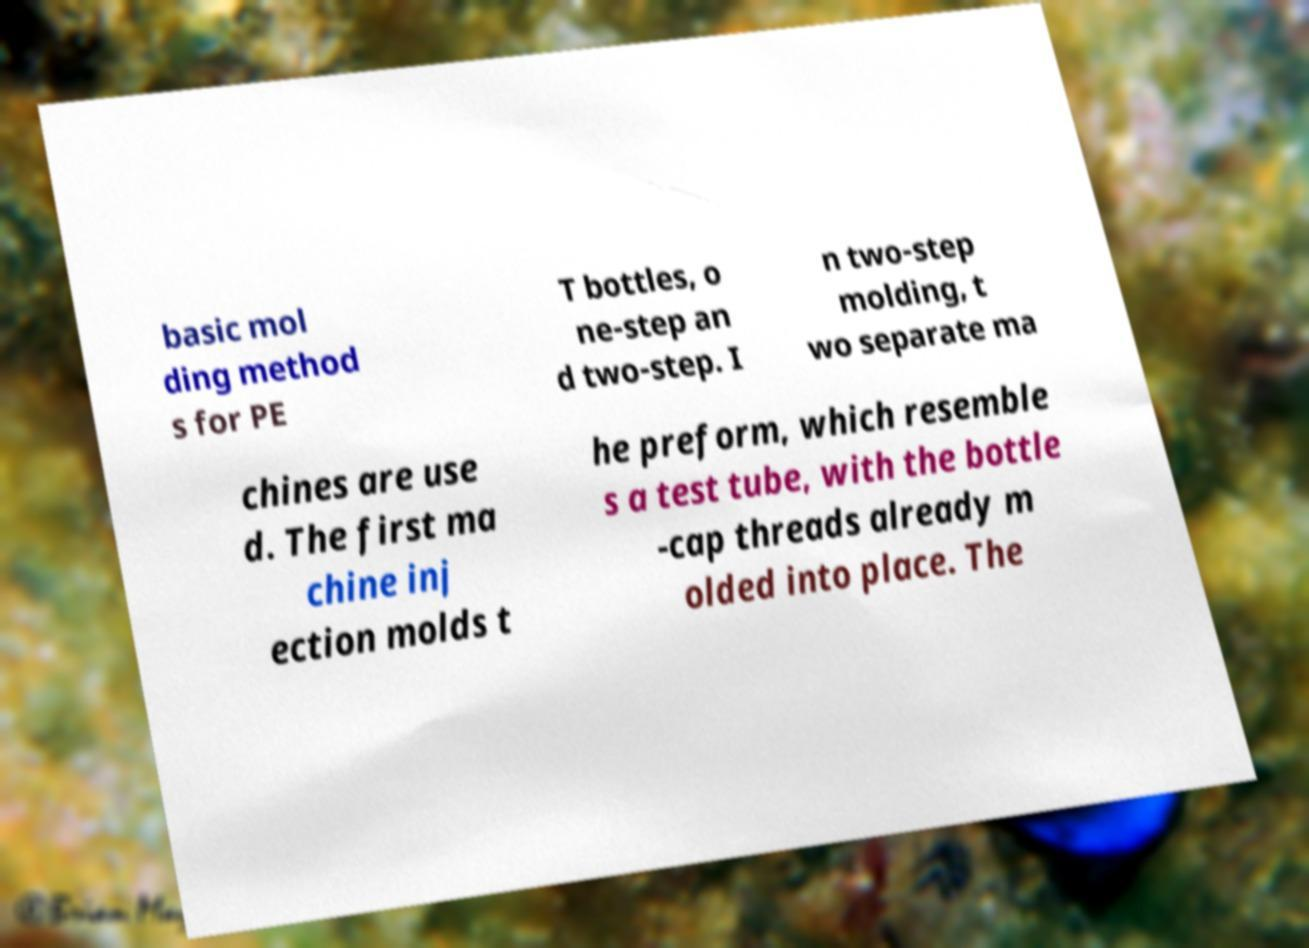Please identify and transcribe the text found in this image. basic mol ding method s for PE T bottles, o ne-step an d two-step. I n two-step molding, t wo separate ma chines are use d. The first ma chine inj ection molds t he preform, which resemble s a test tube, with the bottle -cap threads already m olded into place. The 